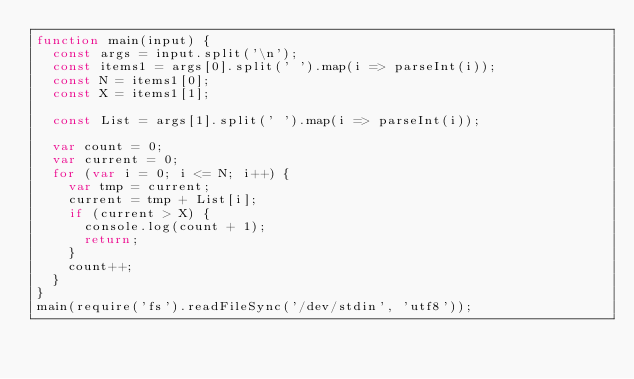Convert code to text. <code><loc_0><loc_0><loc_500><loc_500><_JavaScript_>function main(input) {
  const args = input.split('\n');
  const items1 = args[0].split(' ').map(i => parseInt(i));
  const N = items1[0];
  const X = items1[1];

  const List = args[1].split(' ').map(i => parseInt(i));

  var count = 0;
  var current = 0;
  for (var i = 0; i <= N; i++) {
    var tmp = current;
    current = tmp + List[i];
    if (current > X) {
      console.log(count + 1);
      return;
    }
    count++;
  }
}
main(require('fs').readFileSync('/dev/stdin', 'utf8'));
</code> 